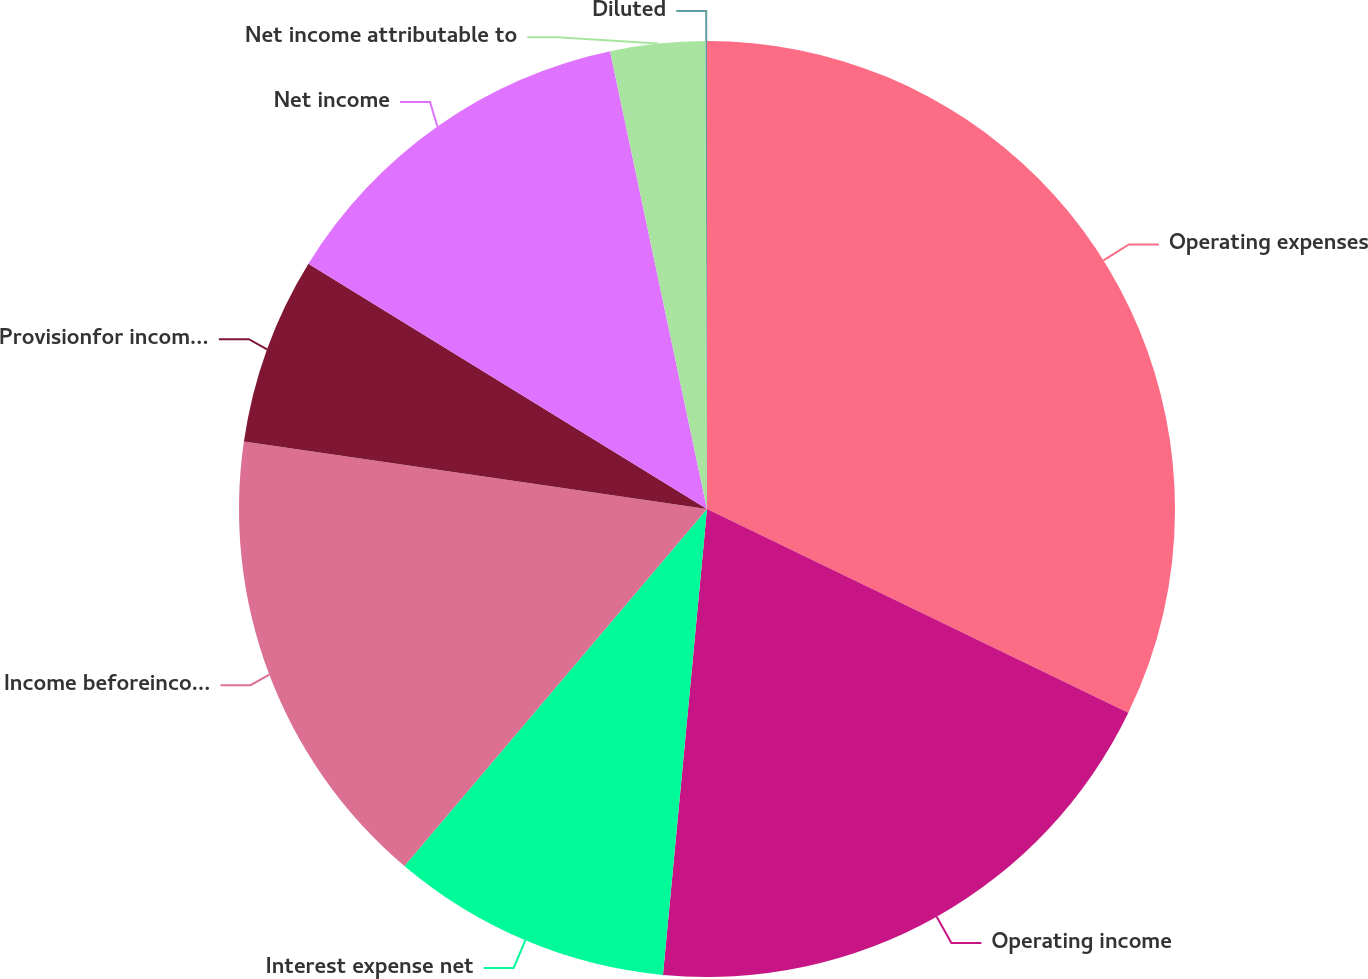Convert chart to OTSL. <chart><loc_0><loc_0><loc_500><loc_500><pie_chart><fcel>Operating expenses<fcel>Operating income<fcel>Interest expense net<fcel>Income beforeincome taxes<fcel>Provisionfor income taxes<fcel>Net income<fcel>Net income attributable to<fcel>Diluted<nl><fcel>32.17%<fcel>19.33%<fcel>9.69%<fcel>16.11%<fcel>6.48%<fcel>12.9%<fcel>3.27%<fcel>0.05%<nl></chart> 